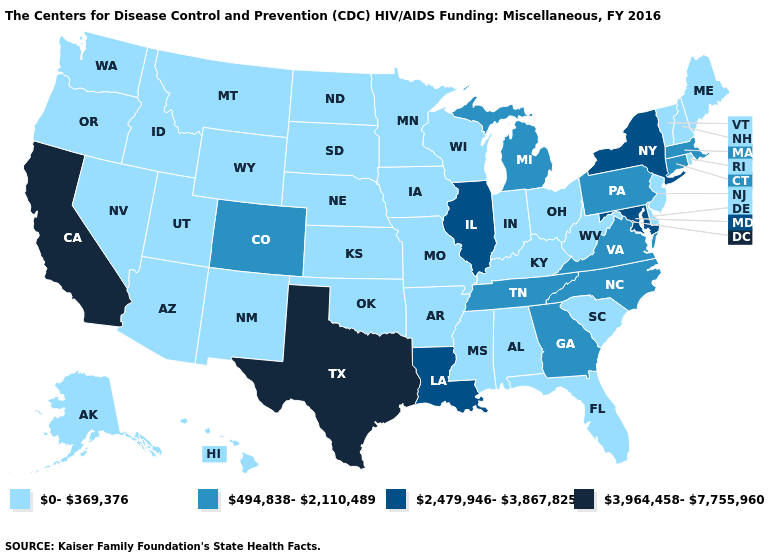Name the states that have a value in the range 3,964,458-7,755,960?
Keep it brief. California, Texas. Name the states that have a value in the range 0-369,376?
Short answer required. Alabama, Alaska, Arizona, Arkansas, Delaware, Florida, Hawaii, Idaho, Indiana, Iowa, Kansas, Kentucky, Maine, Minnesota, Mississippi, Missouri, Montana, Nebraska, Nevada, New Hampshire, New Jersey, New Mexico, North Dakota, Ohio, Oklahoma, Oregon, Rhode Island, South Carolina, South Dakota, Utah, Vermont, Washington, West Virginia, Wisconsin, Wyoming. Among the states that border Minnesota , which have the highest value?
Write a very short answer. Iowa, North Dakota, South Dakota, Wisconsin. Name the states that have a value in the range 3,964,458-7,755,960?
Keep it brief. California, Texas. Name the states that have a value in the range 2,479,946-3,867,825?
Short answer required. Illinois, Louisiana, Maryland, New York. What is the value of Kansas?
Answer briefly. 0-369,376. Which states have the highest value in the USA?
Short answer required. California, Texas. Name the states that have a value in the range 0-369,376?
Give a very brief answer. Alabama, Alaska, Arizona, Arkansas, Delaware, Florida, Hawaii, Idaho, Indiana, Iowa, Kansas, Kentucky, Maine, Minnesota, Mississippi, Missouri, Montana, Nebraska, Nevada, New Hampshire, New Jersey, New Mexico, North Dakota, Ohio, Oklahoma, Oregon, Rhode Island, South Carolina, South Dakota, Utah, Vermont, Washington, West Virginia, Wisconsin, Wyoming. Does the map have missing data?
Answer briefly. No. What is the value of Louisiana?
Answer briefly. 2,479,946-3,867,825. How many symbols are there in the legend?
Keep it brief. 4. What is the value of Pennsylvania?
Keep it brief. 494,838-2,110,489. What is the highest value in the South ?
Answer briefly. 3,964,458-7,755,960. Among the states that border Louisiana , which have the lowest value?
Short answer required. Arkansas, Mississippi. 